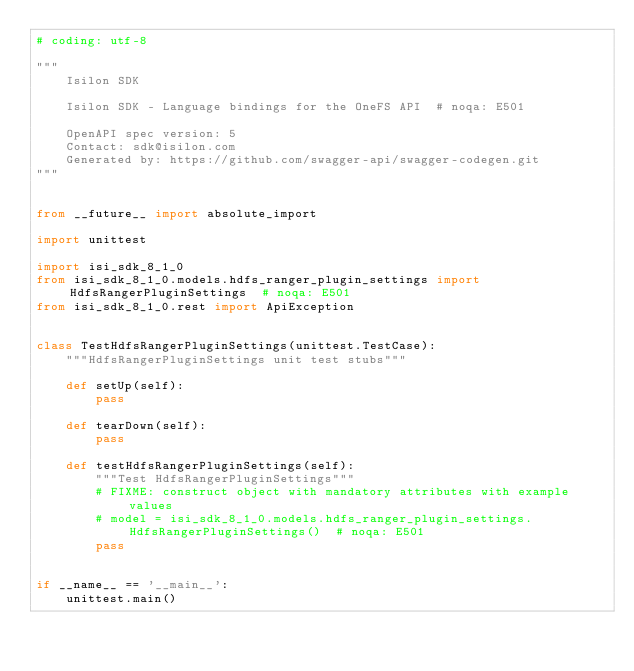<code> <loc_0><loc_0><loc_500><loc_500><_Python_># coding: utf-8

"""
    Isilon SDK

    Isilon SDK - Language bindings for the OneFS API  # noqa: E501

    OpenAPI spec version: 5
    Contact: sdk@isilon.com
    Generated by: https://github.com/swagger-api/swagger-codegen.git
"""


from __future__ import absolute_import

import unittest

import isi_sdk_8_1_0
from isi_sdk_8_1_0.models.hdfs_ranger_plugin_settings import HdfsRangerPluginSettings  # noqa: E501
from isi_sdk_8_1_0.rest import ApiException


class TestHdfsRangerPluginSettings(unittest.TestCase):
    """HdfsRangerPluginSettings unit test stubs"""

    def setUp(self):
        pass

    def tearDown(self):
        pass

    def testHdfsRangerPluginSettings(self):
        """Test HdfsRangerPluginSettings"""
        # FIXME: construct object with mandatory attributes with example values
        # model = isi_sdk_8_1_0.models.hdfs_ranger_plugin_settings.HdfsRangerPluginSettings()  # noqa: E501
        pass


if __name__ == '__main__':
    unittest.main()
</code> 